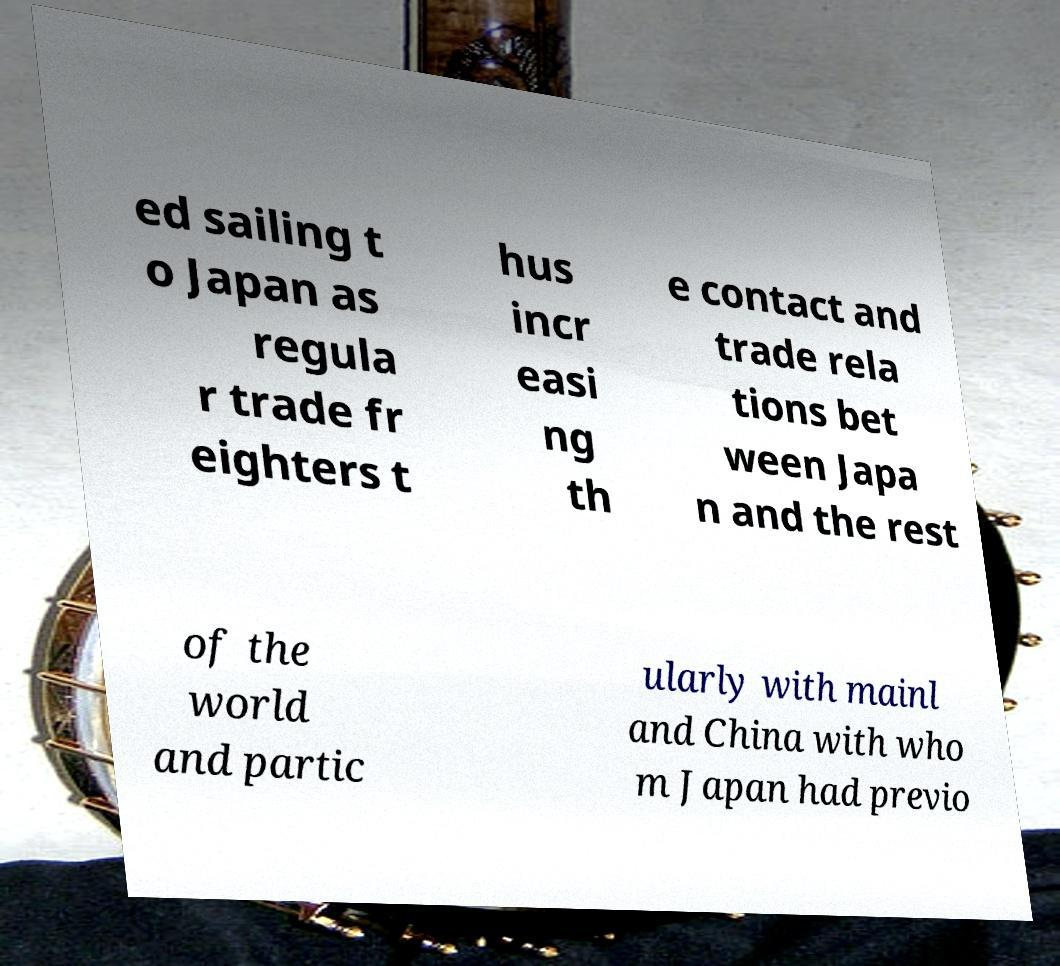Please identify and transcribe the text found in this image. ed sailing t o Japan as regula r trade fr eighters t hus incr easi ng th e contact and trade rela tions bet ween Japa n and the rest of the world and partic ularly with mainl and China with who m Japan had previo 